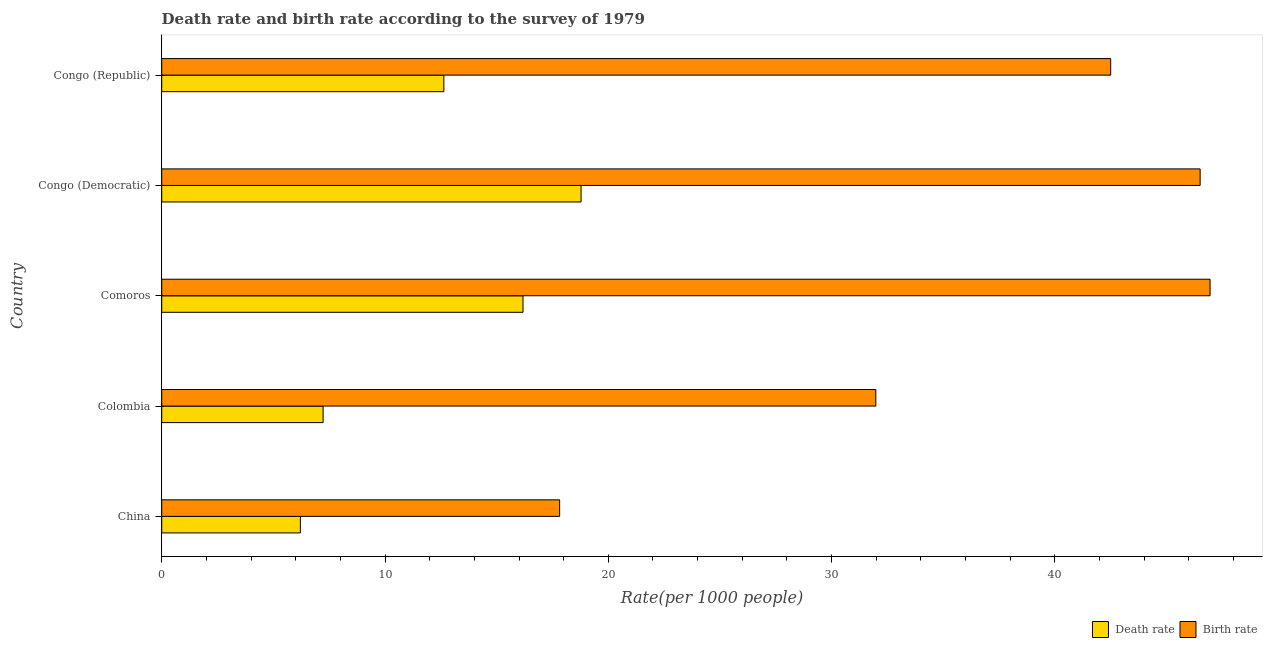How many different coloured bars are there?
Offer a very short reply. 2. Are the number of bars per tick equal to the number of legend labels?
Offer a terse response. Yes. Are the number of bars on each tick of the Y-axis equal?
Ensure brevity in your answer.  Yes. How many bars are there on the 4th tick from the top?
Your response must be concise. 2. What is the label of the 3rd group of bars from the top?
Your answer should be very brief. Comoros. In how many cases, is the number of bars for a given country not equal to the number of legend labels?
Provide a short and direct response. 0. What is the death rate in Colombia?
Ensure brevity in your answer.  7.23. Across all countries, what is the maximum birth rate?
Make the answer very short. 46.95. Across all countries, what is the minimum death rate?
Ensure brevity in your answer.  6.21. In which country was the birth rate maximum?
Your response must be concise. Comoros. In which country was the death rate minimum?
Make the answer very short. China. What is the total death rate in the graph?
Offer a terse response. 61.03. What is the difference between the death rate in China and that in Comoros?
Your answer should be very brief. -9.97. What is the difference between the death rate in China and the birth rate in Congo (Democratic)?
Your answer should be very brief. -40.29. What is the average birth rate per country?
Your answer should be very brief. 37.15. What is the difference between the death rate and birth rate in Comoros?
Make the answer very short. -30.77. In how many countries, is the death rate greater than 14 ?
Ensure brevity in your answer.  2. What is the ratio of the birth rate in Comoros to that in Congo (Republic)?
Provide a succinct answer. 1.1. Is the birth rate in Congo (Democratic) less than that in Congo (Republic)?
Your answer should be compact. No. What is the difference between the highest and the lowest death rate?
Offer a very short reply. 12.57. Is the sum of the death rate in Congo (Democratic) and Congo (Republic) greater than the maximum birth rate across all countries?
Make the answer very short. No. What does the 1st bar from the top in China represents?
Make the answer very short. Birth rate. What does the 2nd bar from the bottom in China represents?
Your answer should be very brief. Birth rate. How many bars are there?
Your answer should be very brief. 10. Does the graph contain grids?
Your answer should be very brief. No. Where does the legend appear in the graph?
Ensure brevity in your answer.  Bottom right. How many legend labels are there?
Provide a short and direct response. 2. How are the legend labels stacked?
Provide a short and direct response. Horizontal. What is the title of the graph?
Offer a very short reply. Death rate and birth rate according to the survey of 1979. Does "Old" appear as one of the legend labels in the graph?
Give a very brief answer. No. What is the label or title of the X-axis?
Offer a very short reply. Rate(per 1000 people). What is the label or title of the Y-axis?
Ensure brevity in your answer.  Country. What is the Rate(per 1000 people) of Death rate in China?
Provide a short and direct response. 6.21. What is the Rate(per 1000 people) in Birth rate in China?
Offer a very short reply. 17.82. What is the Rate(per 1000 people) in Death rate in Colombia?
Your response must be concise. 7.23. What is the Rate(per 1000 people) in Birth rate in Colombia?
Ensure brevity in your answer.  31.98. What is the Rate(per 1000 people) of Death rate in Comoros?
Offer a terse response. 16.18. What is the Rate(per 1000 people) in Birth rate in Comoros?
Your answer should be compact. 46.95. What is the Rate(per 1000 people) of Death rate in Congo (Democratic)?
Your answer should be compact. 18.78. What is the Rate(per 1000 people) in Birth rate in Congo (Democratic)?
Provide a short and direct response. 46.5. What is the Rate(per 1000 people) of Death rate in Congo (Republic)?
Offer a terse response. 12.63. What is the Rate(per 1000 people) of Birth rate in Congo (Republic)?
Keep it short and to the point. 42.5. Across all countries, what is the maximum Rate(per 1000 people) of Death rate?
Your answer should be compact. 18.78. Across all countries, what is the maximum Rate(per 1000 people) of Birth rate?
Provide a short and direct response. 46.95. Across all countries, what is the minimum Rate(per 1000 people) in Death rate?
Keep it short and to the point. 6.21. Across all countries, what is the minimum Rate(per 1000 people) in Birth rate?
Offer a terse response. 17.82. What is the total Rate(per 1000 people) in Death rate in the graph?
Your answer should be compact. 61.03. What is the total Rate(per 1000 people) of Birth rate in the graph?
Your response must be concise. 185.75. What is the difference between the Rate(per 1000 people) of Death rate in China and that in Colombia?
Your answer should be very brief. -1.02. What is the difference between the Rate(per 1000 people) in Birth rate in China and that in Colombia?
Provide a succinct answer. -14.16. What is the difference between the Rate(per 1000 people) of Death rate in China and that in Comoros?
Offer a very short reply. -9.97. What is the difference between the Rate(per 1000 people) in Birth rate in China and that in Comoros?
Offer a very short reply. -29.13. What is the difference between the Rate(per 1000 people) in Death rate in China and that in Congo (Democratic)?
Give a very brief answer. -12.57. What is the difference between the Rate(per 1000 people) in Birth rate in China and that in Congo (Democratic)?
Ensure brevity in your answer.  -28.68. What is the difference between the Rate(per 1000 people) of Death rate in China and that in Congo (Republic)?
Provide a short and direct response. -6.42. What is the difference between the Rate(per 1000 people) of Birth rate in China and that in Congo (Republic)?
Offer a very short reply. -24.68. What is the difference between the Rate(per 1000 people) of Death rate in Colombia and that in Comoros?
Offer a very short reply. -8.95. What is the difference between the Rate(per 1000 people) of Birth rate in Colombia and that in Comoros?
Offer a terse response. -14.97. What is the difference between the Rate(per 1000 people) in Death rate in Colombia and that in Congo (Democratic)?
Provide a succinct answer. -11.55. What is the difference between the Rate(per 1000 people) in Birth rate in Colombia and that in Congo (Democratic)?
Your answer should be very brief. -14.52. What is the difference between the Rate(per 1000 people) of Death rate in Colombia and that in Congo (Republic)?
Make the answer very short. -5.41. What is the difference between the Rate(per 1000 people) of Birth rate in Colombia and that in Congo (Republic)?
Your response must be concise. -10.52. What is the difference between the Rate(per 1000 people) in Birth rate in Comoros and that in Congo (Democratic)?
Make the answer very short. 0.45. What is the difference between the Rate(per 1000 people) of Death rate in Comoros and that in Congo (Republic)?
Keep it short and to the point. 3.54. What is the difference between the Rate(per 1000 people) in Birth rate in Comoros and that in Congo (Republic)?
Provide a succinct answer. 4.45. What is the difference between the Rate(per 1000 people) of Death rate in Congo (Democratic) and that in Congo (Republic)?
Provide a short and direct response. 6.14. What is the difference between the Rate(per 1000 people) of Birth rate in Congo (Democratic) and that in Congo (Republic)?
Your response must be concise. 4.01. What is the difference between the Rate(per 1000 people) in Death rate in China and the Rate(per 1000 people) in Birth rate in Colombia?
Provide a short and direct response. -25.77. What is the difference between the Rate(per 1000 people) of Death rate in China and the Rate(per 1000 people) of Birth rate in Comoros?
Your answer should be very brief. -40.74. What is the difference between the Rate(per 1000 people) in Death rate in China and the Rate(per 1000 people) in Birth rate in Congo (Democratic)?
Keep it short and to the point. -40.29. What is the difference between the Rate(per 1000 people) of Death rate in China and the Rate(per 1000 people) of Birth rate in Congo (Republic)?
Ensure brevity in your answer.  -36.29. What is the difference between the Rate(per 1000 people) of Death rate in Colombia and the Rate(per 1000 people) of Birth rate in Comoros?
Give a very brief answer. -39.72. What is the difference between the Rate(per 1000 people) in Death rate in Colombia and the Rate(per 1000 people) in Birth rate in Congo (Democratic)?
Your answer should be compact. -39.27. What is the difference between the Rate(per 1000 people) in Death rate in Colombia and the Rate(per 1000 people) in Birth rate in Congo (Republic)?
Give a very brief answer. -35.27. What is the difference between the Rate(per 1000 people) of Death rate in Comoros and the Rate(per 1000 people) of Birth rate in Congo (Democratic)?
Offer a terse response. -30.32. What is the difference between the Rate(per 1000 people) in Death rate in Comoros and the Rate(per 1000 people) in Birth rate in Congo (Republic)?
Ensure brevity in your answer.  -26.32. What is the difference between the Rate(per 1000 people) of Death rate in Congo (Democratic) and the Rate(per 1000 people) of Birth rate in Congo (Republic)?
Your answer should be compact. -23.72. What is the average Rate(per 1000 people) in Death rate per country?
Provide a short and direct response. 12.21. What is the average Rate(per 1000 people) of Birth rate per country?
Provide a short and direct response. 37.15. What is the difference between the Rate(per 1000 people) in Death rate and Rate(per 1000 people) in Birth rate in China?
Keep it short and to the point. -11.61. What is the difference between the Rate(per 1000 people) in Death rate and Rate(per 1000 people) in Birth rate in Colombia?
Offer a very short reply. -24.75. What is the difference between the Rate(per 1000 people) of Death rate and Rate(per 1000 people) of Birth rate in Comoros?
Offer a very short reply. -30.77. What is the difference between the Rate(per 1000 people) in Death rate and Rate(per 1000 people) in Birth rate in Congo (Democratic)?
Keep it short and to the point. -27.72. What is the difference between the Rate(per 1000 people) of Death rate and Rate(per 1000 people) of Birth rate in Congo (Republic)?
Your answer should be compact. -29.86. What is the ratio of the Rate(per 1000 people) of Death rate in China to that in Colombia?
Offer a very short reply. 0.86. What is the ratio of the Rate(per 1000 people) of Birth rate in China to that in Colombia?
Your response must be concise. 0.56. What is the ratio of the Rate(per 1000 people) of Death rate in China to that in Comoros?
Offer a terse response. 0.38. What is the ratio of the Rate(per 1000 people) in Birth rate in China to that in Comoros?
Offer a terse response. 0.38. What is the ratio of the Rate(per 1000 people) of Death rate in China to that in Congo (Democratic)?
Offer a terse response. 0.33. What is the ratio of the Rate(per 1000 people) of Birth rate in China to that in Congo (Democratic)?
Your answer should be very brief. 0.38. What is the ratio of the Rate(per 1000 people) in Death rate in China to that in Congo (Republic)?
Offer a very short reply. 0.49. What is the ratio of the Rate(per 1000 people) of Birth rate in China to that in Congo (Republic)?
Offer a very short reply. 0.42. What is the ratio of the Rate(per 1000 people) of Death rate in Colombia to that in Comoros?
Make the answer very short. 0.45. What is the ratio of the Rate(per 1000 people) in Birth rate in Colombia to that in Comoros?
Your answer should be compact. 0.68. What is the ratio of the Rate(per 1000 people) of Death rate in Colombia to that in Congo (Democratic)?
Ensure brevity in your answer.  0.38. What is the ratio of the Rate(per 1000 people) of Birth rate in Colombia to that in Congo (Democratic)?
Your answer should be compact. 0.69. What is the ratio of the Rate(per 1000 people) in Death rate in Colombia to that in Congo (Republic)?
Your response must be concise. 0.57. What is the ratio of the Rate(per 1000 people) in Birth rate in Colombia to that in Congo (Republic)?
Ensure brevity in your answer.  0.75. What is the ratio of the Rate(per 1000 people) in Death rate in Comoros to that in Congo (Democratic)?
Your answer should be very brief. 0.86. What is the ratio of the Rate(per 1000 people) of Birth rate in Comoros to that in Congo (Democratic)?
Your answer should be compact. 1.01. What is the ratio of the Rate(per 1000 people) in Death rate in Comoros to that in Congo (Republic)?
Provide a succinct answer. 1.28. What is the ratio of the Rate(per 1000 people) in Birth rate in Comoros to that in Congo (Republic)?
Keep it short and to the point. 1.1. What is the ratio of the Rate(per 1000 people) of Death rate in Congo (Democratic) to that in Congo (Republic)?
Provide a short and direct response. 1.49. What is the ratio of the Rate(per 1000 people) of Birth rate in Congo (Democratic) to that in Congo (Republic)?
Provide a short and direct response. 1.09. What is the difference between the highest and the second highest Rate(per 1000 people) in Birth rate?
Provide a short and direct response. 0.45. What is the difference between the highest and the lowest Rate(per 1000 people) of Death rate?
Offer a terse response. 12.57. What is the difference between the highest and the lowest Rate(per 1000 people) of Birth rate?
Offer a very short reply. 29.13. 